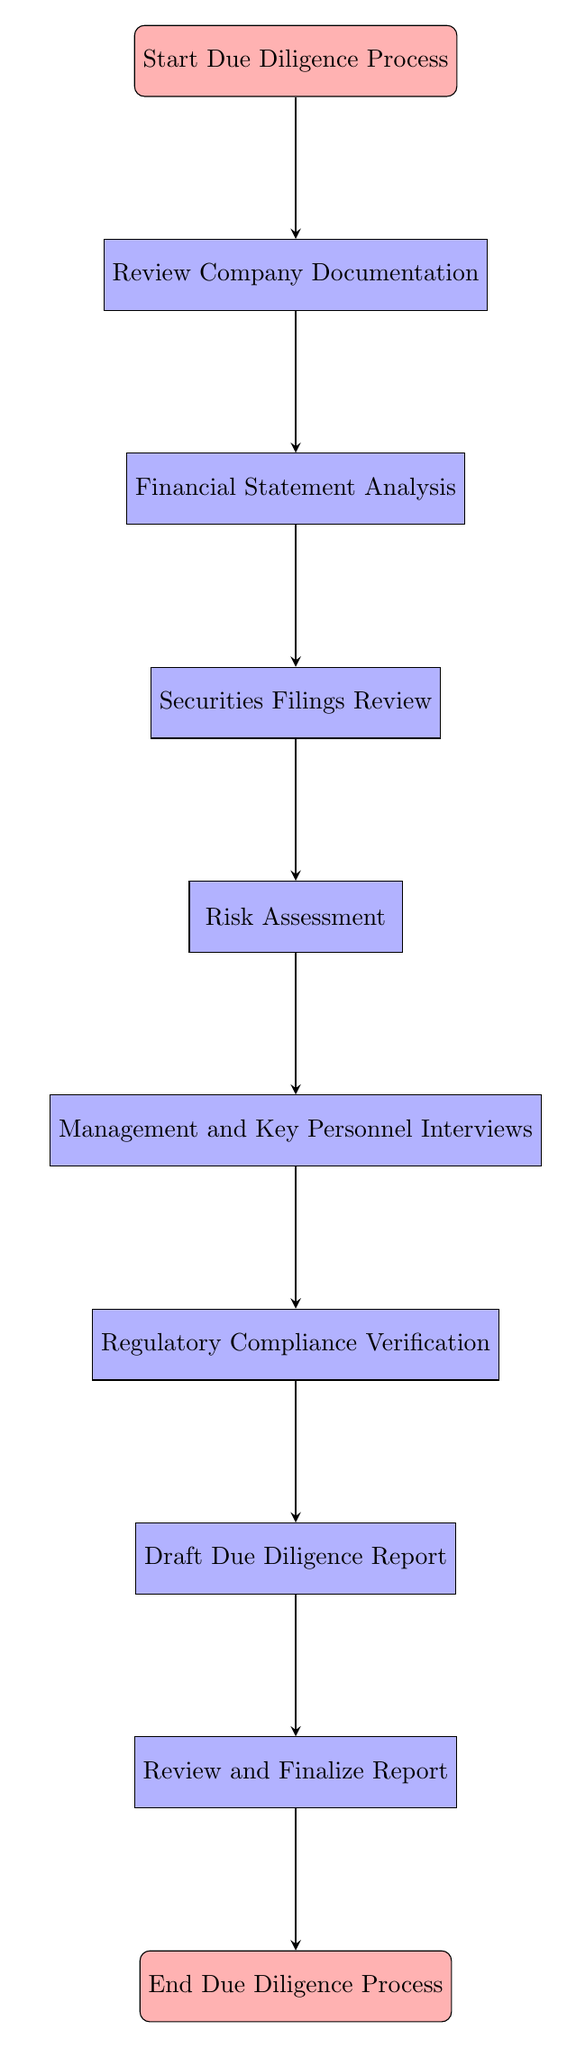What is the first step in the due diligence process? The first step is indicated by the top node labeled "Start Due Diligence Process," which signifies where the flow begins.
Answer: Start Due Diligence Process How many total nodes are present in the flow chart? By counting all the distinct elements from "Start Due Diligence Process" to "End Due Diligence Process," we identify 10 nodes in total.
Answer: 10 What is the last step before concluding the due diligence process? The last step before concluding is specified by the node labeled "Review and Finalize Report," which directly precedes the final end node.
Answer: Review and Finalize Report What two steps follow the "Financial Statement Analysis"? The flow chart indicates that "Securities Filings Review" and "Risk Assessment" are the two subsequent steps, following directly below "Financial Statement Analysis."
Answer: Securities Filings Review, Risk Assessment What step involves conducting interviews with key personnel? The step corresponding to conducting interviews is clearly labeled "Management and Key Personnel Interviews" and is represented in the flow chart as the sixth node down from the start.
Answer: Management and Key Personnel Interviews What is the sequential order of the first three steps in the flow chart? The flow indicates that the first three steps are "Review Company Documentation," "Financial Statement Analysis," and "Securities Filings Review," with each step leading sequentially to the next.
Answer: Review Company Documentation, Financial Statement Analysis, Securities Filings Review Which node directly precedes the "Draft Due Diligence Report"? The node that directly precedes "Draft Due Diligence Report" is "Regulatory Compliance Verification," which is indicated as the step immediately above it in the diagram.
Answer: Regulatory Compliance Verification What are the regulations mentioned in the "Regulatory Compliance Verification"? The regulations specified in that step are the Securities Act of 1933, and the Securities Exchange Act of 1934, both of which are critical components of compliance verification.
Answer: Securities Act of 1933, Securities Exchange Act of 1934 Which steps are involved in the risk assessment phase? The risk assessment phase includes identifying and evaluating legal, financial, and operational risks, as indicated in the node labeled "Risk Assessment."
Answer: Identify and evaluate legal, financial, and operational risks What stage comes after verifying regulatory compliance? The stage that follows verifying regulatory compliance is drafting the due diligence report, as indicated by the flow from "Regulatory Compliance Verification" to "Draft Due Diligence Report."
Answer: Draft Due Diligence Report 